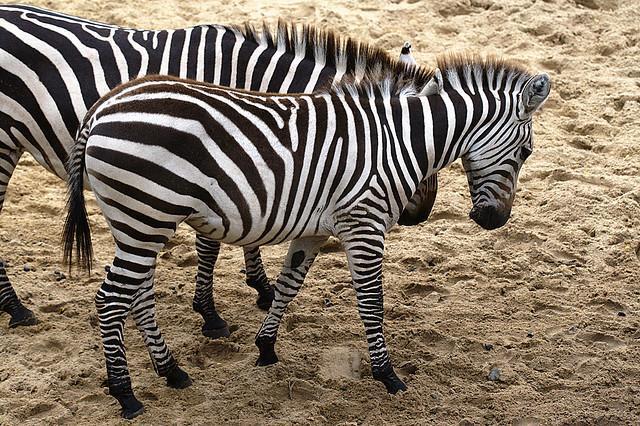How many zebras are shown?
Give a very brief answer. 2. How many zebras are there?
Give a very brief answer. 2. How many zebras can be seen?
Give a very brief answer. 2. 